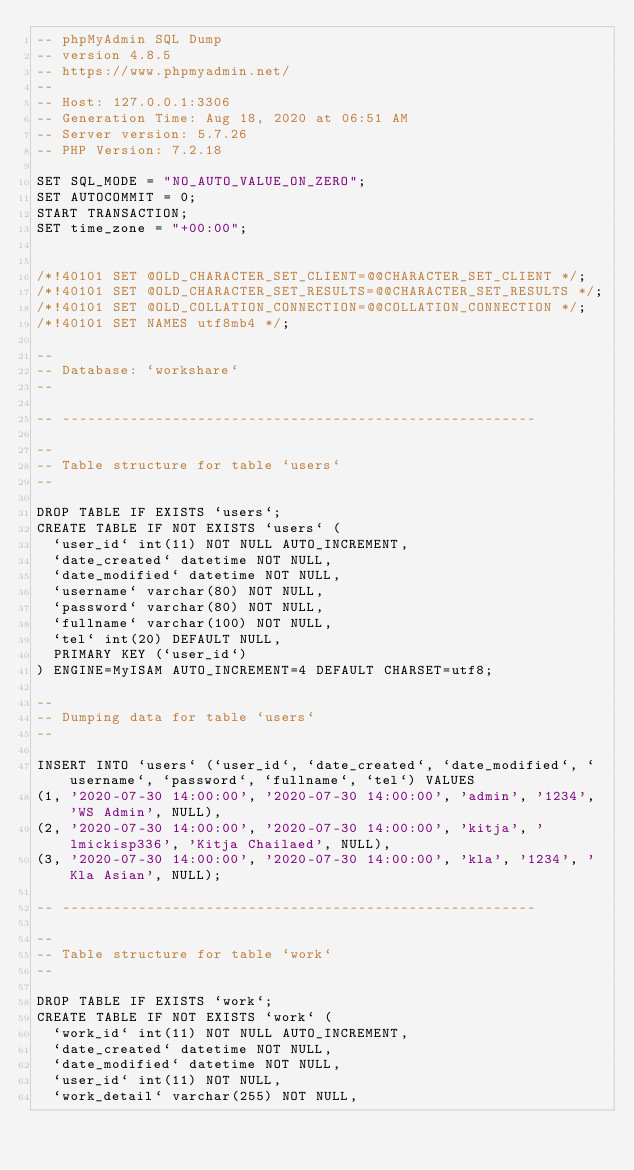<code> <loc_0><loc_0><loc_500><loc_500><_SQL_>-- phpMyAdmin SQL Dump
-- version 4.8.5
-- https://www.phpmyadmin.net/
--
-- Host: 127.0.0.1:3306
-- Generation Time: Aug 18, 2020 at 06:51 AM
-- Server version: 5.7.26
-- PHP Version: 7.2.18

SET SQL_MODE = "NO_AUTO_VALUE_ON_ZERO";
SET AUTOCOMMIT = 0;
START TRANSACTION;
SET time_zone = "+00:00";


/*!40101 SET @OLD_CHARACTER_SET_CLIENT=@@CHARACTER_SET_CLIENT */;
/*!40101 SET @OLD_CHARACTER_SET_RESULTS=@@CHARACTER_SET_RESULTS */;
/*!40101 SET @OLD_COLLATION_CONNECTION=@@COLLATION_CONNECTION */;
/*!40101 SET NAMES utf8mb4 */;

--
-- Database: `workshare`
--

-- --------------------------------------------------------

--
-- Table structure for table `users`
--

DROP TABLE IF EXISTS `users`;
CREATE TABLE IF NOT EXISTS `users` (
  `user_id` int(11) NOT NULL AUTO_INCREMENT,
  `date_created` datetime NOT NULL,
  `date_modified` datetime NOT NULL,
  `username` varchar(80) NOT NULL,
  `password` varchar(80) NOT NULL,
  `fullname` varchar(100) NOT NULL,
  `tel` int(20) DEFAULT NULL,
  PRIMARY KEY (`user_id`)
) ENGINE=MyISAM AUTO_INCREMENT=4 DEFAULT CHARSET=utf8;

--
-- Dumping data for table `users`
--

INSERT INTO `users` (`user_id`, `date_created`, `date_modified`, `username`, `password`, `fullname`, `tel`) VALUES
(1, '2020-07-30 14:00:00', '2020-07-30 14:00:00', 'admin', '1234', 'WS Admin', NULL),
(2, '2020-07-30 14:00:00', '2020-07-30 14:00:00', 'kitja', 'lmickisp336', 'Kitja Chailaed', NULL),
(3, '2020-07-30 14:00:00', '2020-07-30 14:00:00', 'kla', '1234', 'Kla Asian', NULL);

-- --------------------------------------------------------

--
-- Table structure for table `work`
--

DROP TABLE IF EXISTS `work`;
CREATE TABLE IF NOT EXISTS `work` (
  `work_id` int(11) NOT NULL AUTO_INCREMENT,
  `date_created` datetime NOT NULL,
  `date_modified` datetime NOT NULL,
  `user_id` int(11) NOT NULL,
  `work_detail` varchar(255) NOT NULL,</code> 